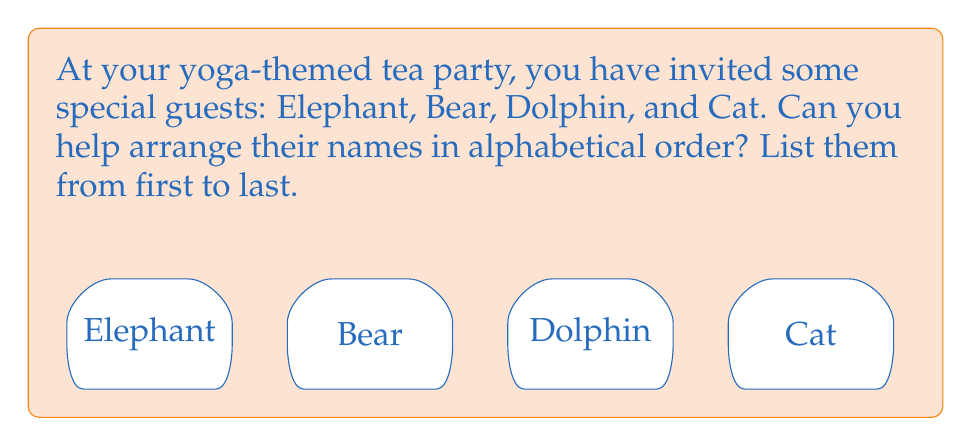Teach me how to tackle this problem. Let's approach this step-by-step:

1) First, we need to look at the first letter of each animal's name:
   - Elephant starts with E
   - Bear starts with B
   - Dolphin starts with D
   - Cat starts with C

2) Now, let's recall the order of these letters in the alphabet:
   B comes first, then C, then D, and finally E.

3) So, we can arrange the animals in this order:
   Bear (B), Cat (C), Dolphin (D), Elephant (E)

4) This gives us our final alphabetical order:
   Bear, Cat, Dolphin, Elephant

Remember, in alphabetical order, we always start with the letter that comes first in the alphabet and move towards the end.
Answer: Bear, Cat, Dolphin, Elephant 